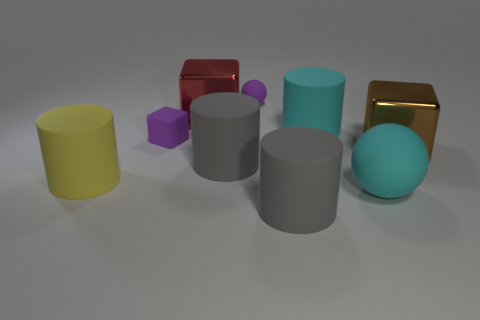How many objects are either spheres behind the cyan rubber ball or big matte cylinders that are in front of the large yellow thing?
Offer a terse response. 2. Is the number of yellow matte cylinders to the right of the big brown block greater than the number of brown objects that are to the right of the big yellow matte thing?
Give a very brief answer. No. There is a cyan thing that is in front of the metallic block to the right of the gray matte thing in front of the yellow rubber thing; what is it made of?
Give a very brief answer. Rubber. Do the cyan rubber object behind the large brown object and the gray object that is behind the yellow matte thing have the same shape?
Offer a very short reply. Yes. Are there any red metallic objects of the same size as the cyan rubber cylinder?
Ensure brevity in your answer.  Yes. What number of purple things are either tiny things or rubber blocks?
Give a very brief answer. 2. What number of rubber objects have the same color as the tiny rubber ball?
Your response must be concise. 1. Is there any other thing that has the same shape as the yellow object?
Your answer should be compact. Yes. How many spheres are big rubber objects or big green objects?
Give a very brief answer. 1. The ball that is in front of the purple rubber block is what color?
Your answer should be very brief. Cyan. 